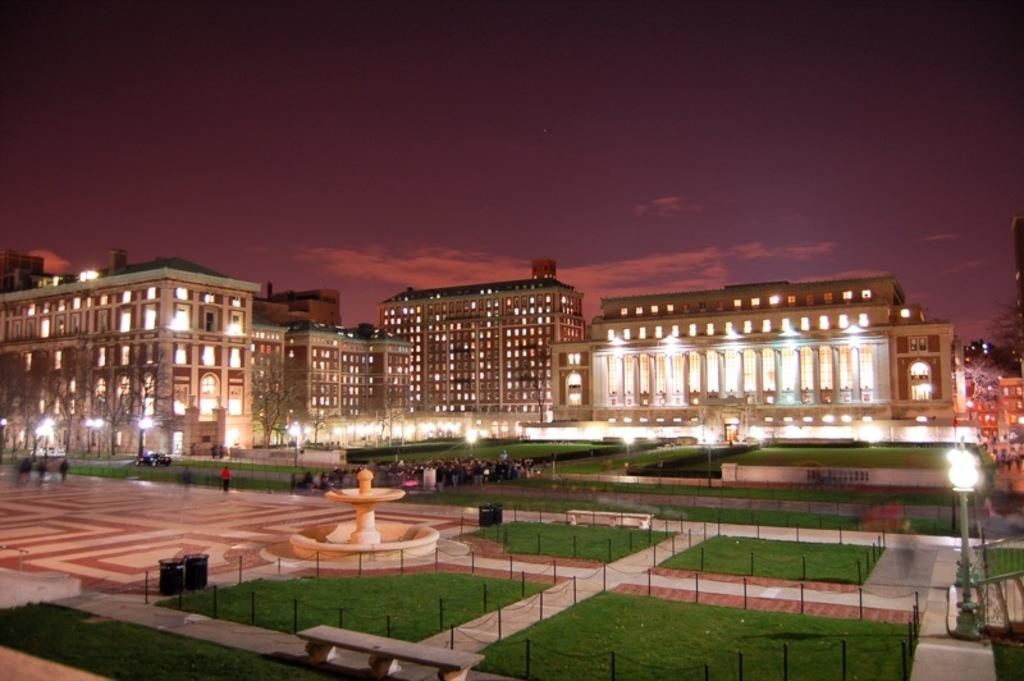What can be seen in the background of the image? There are buildings in the background of the image. What type of vegetation is at the bottom of the image? There is grass at the bottom of the image. What safety features are present in the image? There are safety poles in the image. Who or what is present in the image? There are people in the image. What water feature can be seen in the image? There is a fountain in the image. How many mice are participating in the test depicted in the image? There are no mice or tests present in the image. What type of voyage is being undertaken by the people in the image? There is no voyage depicted in the image; it simply shows people, buildings, grass, safety poles, and a fountain. 